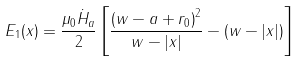Convert formula to latex. <formula><loc_0><loc_0><loc_500><loc_500>E _ { 1 } ( x ) = \frac { \mu _ { 0 } \dot { H } _ { a } } { 2 } \left [ \frac { \left ( w - a + r _ { 0 } \right ) ^ { 2 } } { w - | x | } - ( w - | x | ) \right ]</formula> 